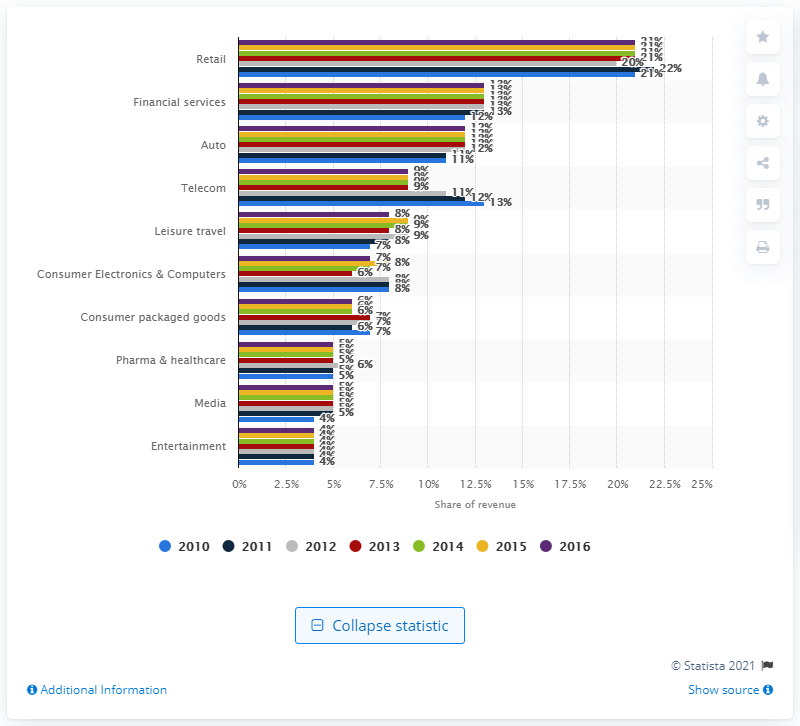Give some essential details in this illustration. In 2016, financial services companies accounted for approximately 13% of online advertising revenue. 